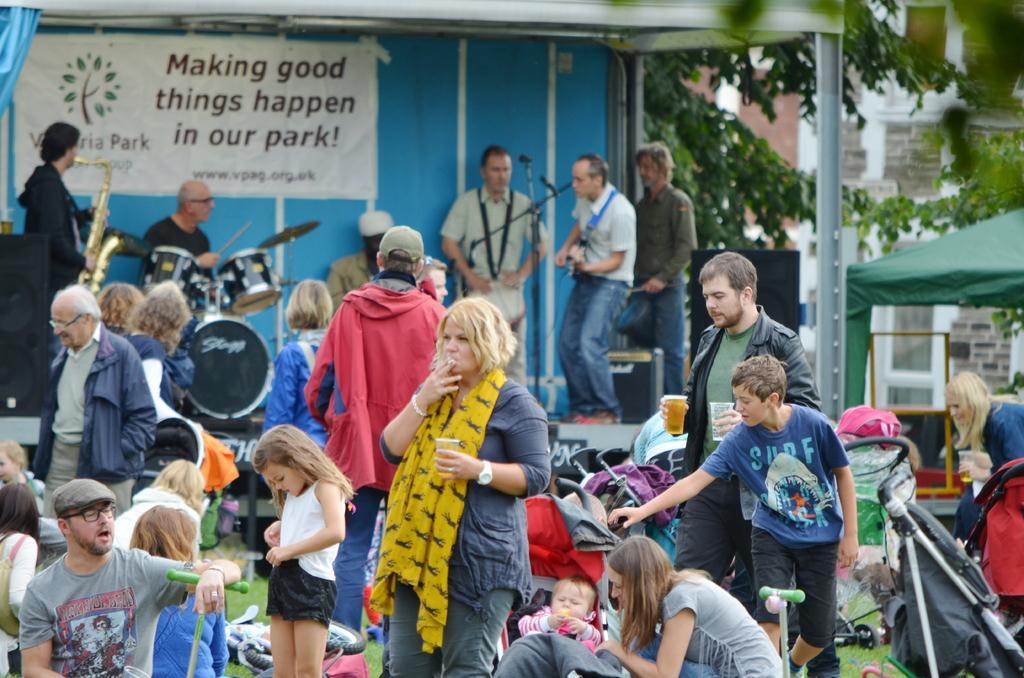How would you summarize this image in a sentence or two? In this picture we can see a group of people, musical instruments, mics, banner, clothes, tent, speakers, some objects and in the background we can see a building, trees. 